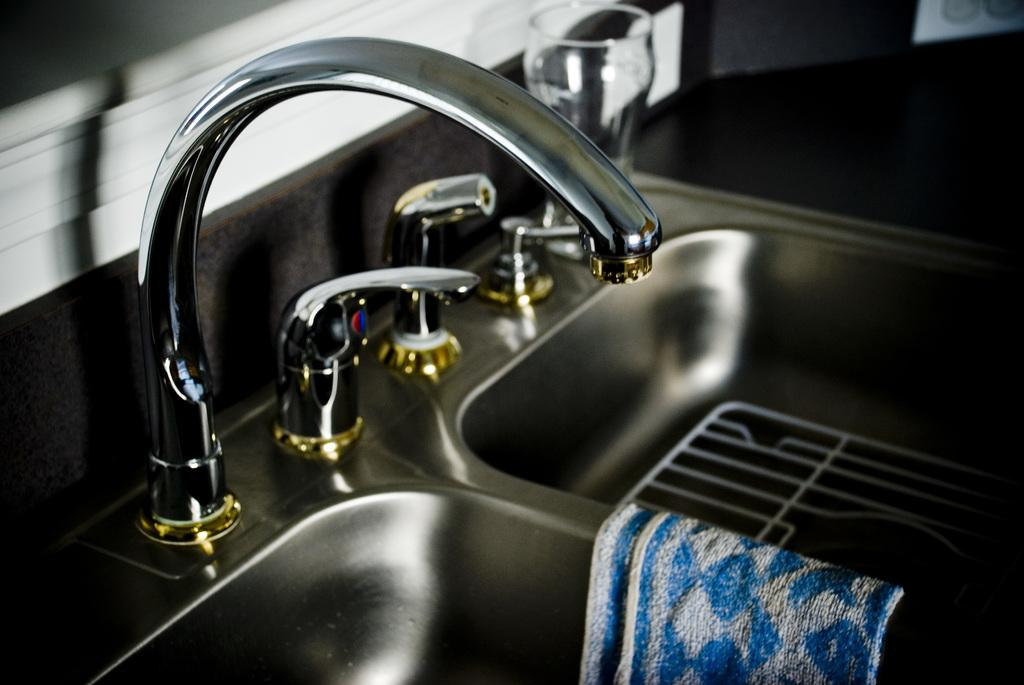What type of fixtures are present in the image? There are sinks and taps in the image. What object is visible near the sinks? There is a glass in the image. What item might be used for drying hands in the image? There is a towel in the image. What type of structure is visible in the background of the image? There is a wall in the image. What type of lunchroom is visible in the image? There is no lunchroom present in the image. Can you describe the person offering a drink in the image? There is no person present in the image, and therefore no one is offering a drink. 